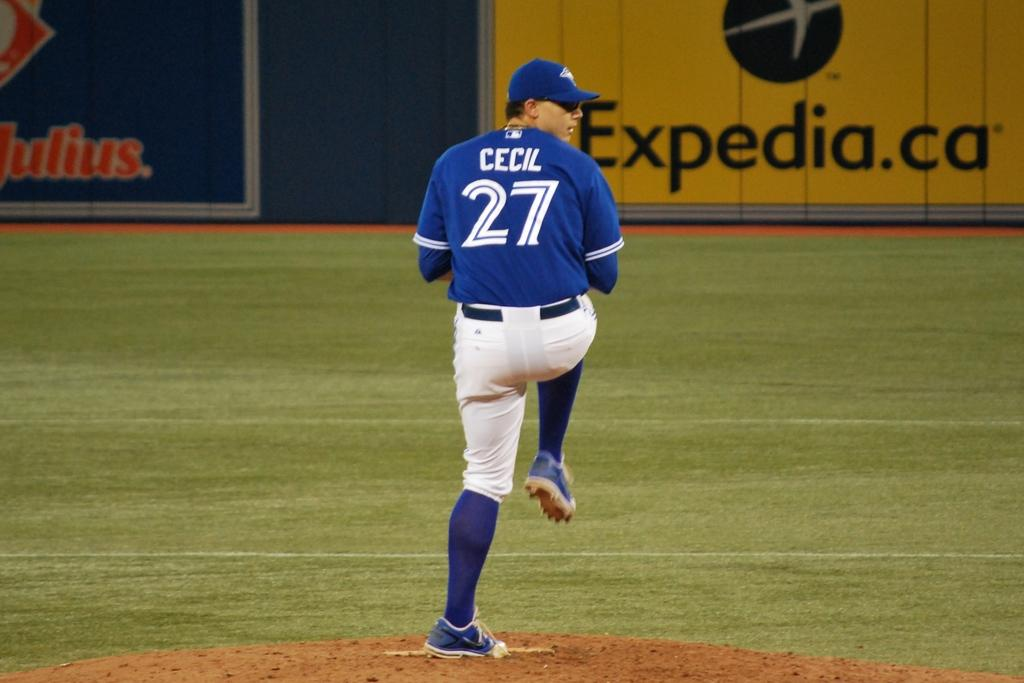<image>
Relay a brief, clear account of the picture shown. a Blue Jays player that has the number 27 on their jersey 